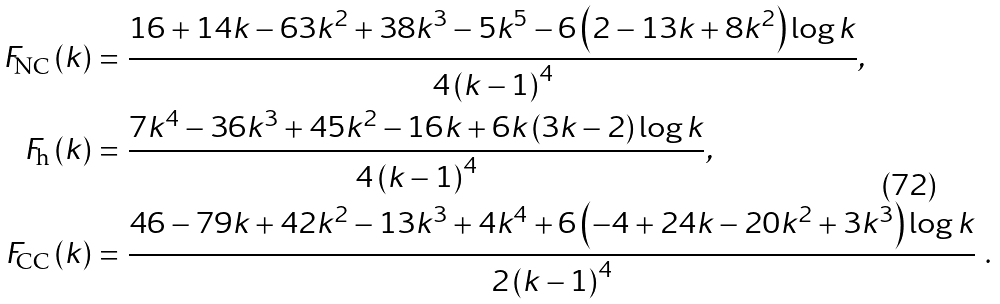Convert formula to latex. <formula><loc_0><loc_0><loc_500><loc_500>F _ { \text {NC} } \left ( k \right ) = & \ \frac { 1 6 + 1 4 k - 6 3 k ^ { 2 } + 3 8 k ^ { 3 } - 5 k ^ { 5 } - 6 \left ( 2 - 1 3 k + 8 k ^ { 2 } \right ) \log k } { 4 \left ( k - 1 \right ) ^ { 4 } } , \\ F _ { \text {h} } \left ( k \right ) = & \ \frac { 7 k ^ { 4 } - 3 6 k ^ { 3 } + 4 5 k ^ { 2 } - 1 6 k + 6 k \left ( 3 k - 2 \right ) \log k } { 4 \left ( k - 1 \right ) ^ { 4 } } , \\ F _ { \text {CC} } \left ( k \right ) = & \ \frac { 4 6 - 7 9 k + 4 2 k ^ { 2 } - 1 3 k ^ { 3 } + 4 k ^ { 4 } + 6 \left ( - 4 + 2 4 k - 2 0 k ^ { 2 } + 3 k ^ { 3 } \right ) \log k } { 2 \left ( k - 1 \right ) ^ { 4 } } \ .</formula> 